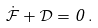Convert formula to latex. <formula><loc_0><loc_0><loc_500><loc_500>\mathcal { \dot { F } } + \mathcal { D } = 0 \, .</formula> 